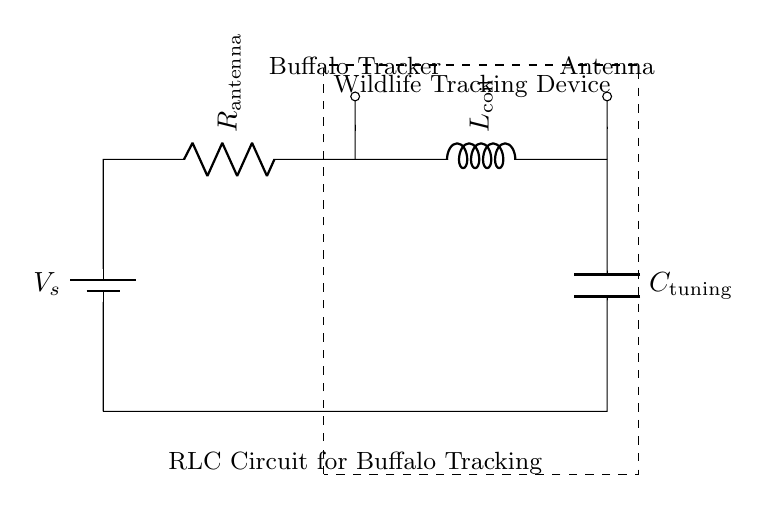What components are present in this circuit? The components visible in the diagram include a battery, resistor, inductor, and capacitor. Each is labeled, making it straightforward to identify them.
Answer: battery, resistor, inductor, capacitor What is the function of the capacitor in this circuit? The capacitor's role is to store electrical energy and help in tuning the circuit for optimal frequency response, which is crucial for effective communication in tracking devices.
Answer: tuning What does R represent in this circuit? R represents the resistor, specifically identified as R antenna, which likely relates to the load or impedance matching in the network to the antenna.
Answer: R antenna How does the inductor affect signal transmission? The inductor provides reactance which, in conjunction with the resistor and capacitor, influences the overall impedance of the circuit. This impacts resonant frequency, affecting signal quality and range for wildlife tracking.
Answer: reactance What type of circuit is depicted here? The circuit shown is an RLC circuit, which involves a resistor, inductor, and capacitor connected in series, typical for applications such as tuning or filtering in radio frequency systems.
Answer: RLC circuit 